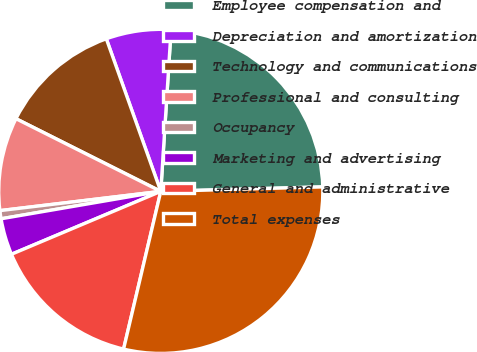Convert chart. <chart><loc_0><loc_0><loc_500><loc_500><pie_chart><fcel>Employee compensation and<fcel>Depreciation and amortization<fcel>Technology and communications<fcel>Professional and consulting<fcel>Occupancy<fcel>Marketing and advertising<fcel>General and administrative<fcel>Total expenses<nl><fcel>23.55%<fcel>6.47%<fcel>12.14%<fcel>9.3%<fcel>0.81%<fcel>3.64%<fcel>14.97%<fcel>29.13%<nl></chart> 